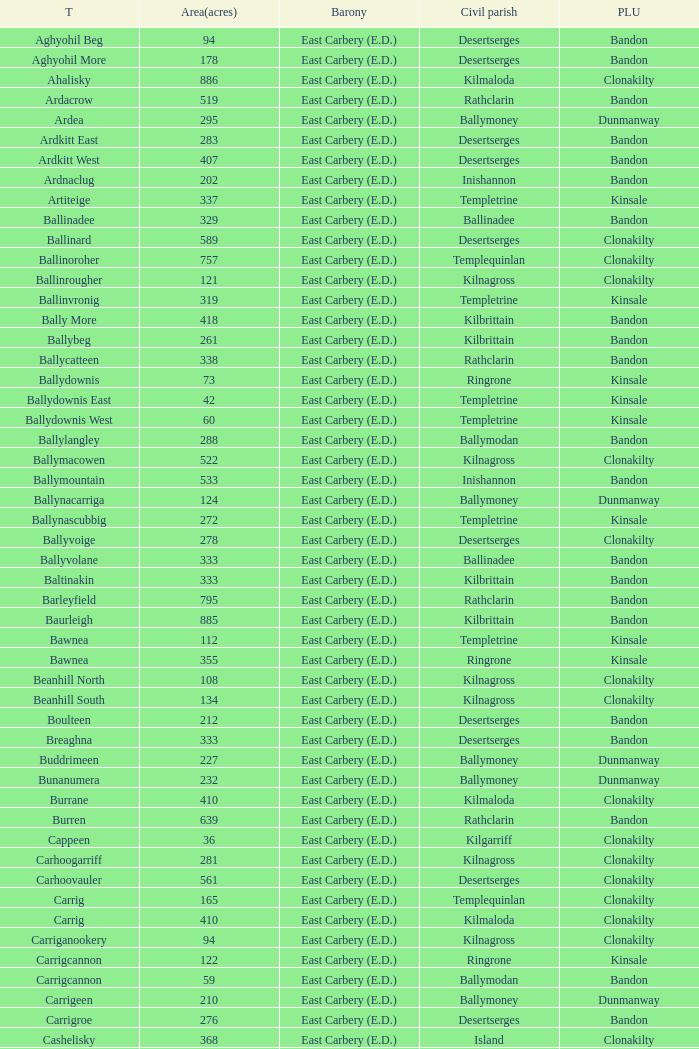What is the maximum area (in acres) of the Knockacullen townland? 381.0. Parse the full table. {'header': ['T', 'Area(acres)', 'Barony', 'Civil parish', 'PLU'], 'rows': [['Aghyohil Beg', '94', 'East Carbery (E.D.)', 'Desertserges', 'Bandon'], ['Aghyohil More', '178', 'East Carbery (E.D.)', 'Desertserges', 'Bandon'], ['Ahalisky', '886', 'East Carbery (E.D.)', 'Kilmaloda', 'Clonakilty'], ['Ardacrow', '519', 'East Carbery (E.D.)', 'Rathclarin', 'Bandon'], ['Ardea', '295', 'East Carbery (E.D.)', 'Ballymoney', 'Dunmanway'], ['Ardkitt East', '283', 'East Carbery (E.D.)', 'Desertserges', 'Bandon'], ['Ardkitt West', '407', 'East Carbery (E.D.)', 'Desertserges', 'Bandon'], ['Ardnaclug', '202', 'East Carbery (E.D.)', 'Inishannon', 'Bandon'], ['Artiteige', '337', 'East Carbery (E.D.)', 'Templetrine', 'Kinsale'], ['Ballinadee', '329', 'East Carbery (E.D.)', 'Ballinadee', 'Bandon'], ['Ballinard', '589', 'East Carbery (E.D.)', 'Desertserges', 'Clonakilty'], ['Ballinoroher', '757', 'East Carbery (E.D.)', 'Templequinlan', 'Clonakilty'], ['Ballinrougher', '121', 'East Carbery (E.D.)', 'Kilnagross', 'Clonakilty'], ['Ballinvronig', '319', 'East Carbery (E.D.)', 'Templetrine', 'Kinsale'], ['Bally More', '418', 'East Carbery (E.D.)', 'Kilbrittain', 'Bandon'], ['Ballybeg', '261', 'East Carbery (E.D.)', 'Kilbrittain', 'Bandon'], ['Ballycatteen', '338', 'East Carbery (E.D.)', 'Rathclarin', 'Bandon'], ['Ballydownis', '73', 'East Carbery (E.D.)', 'Ringrone', 'Kinsale'], ['Ballydownis East', '42', 'East Carbery (E.D.)', 'Templetrine', 'Kinsale'], ['Ballydownis West', '60', 'East Carbery (E.D.)', 'Templetrine', 'Kinsale'], ['Ballylangley', '288', 'East Carbery (E.D.)', 'Ballymodan', 'Bandon'], ['Ballymacowen', '522', 'East Carbery (E.D.)', 'Kilnagross', 'Clonakilty'], ['Ballymountain', '533', 'East Carbery (E.D.)', 'Inishannon', 'Bandon'], ['Ballynacarriga', '124', 'East Carbery (E.D.)', 'Ballymoney', 'Dunmanway'], ['Ballynascubbig', '272', 'East Carbery (E.D.)', 'Templetrine', 'Kinsale'], ['Ballyvoige', '278', 'East Carbery (E.D.)', 'Desertserges', 'Clonakilty'], ['Ballyvolane', '333', 'East Carbery (E.D.)', 'Ballinadee', 'Bandon'], ['Baltinakin', '333', 'East Carbery (E.D.)', 'Kilbrittain', 'Bandon'], ['Barleyfield', '795', 'East Carbery (E.D.)', 'Rathclarin', 'Bandon'], ['Baurleigh', '885', 'East Carbery (E.D.)', 'Kilbrittain', 'Bandon'], ['Bawnea', '112', 'East Carbery (E.D.)', 'Templetrine', 'Kinsale'], ['Bawnea', '355', 'East Carbery (E.D.)', 'Ringrone', 'Kinsale'], ['Beanhill North', '108', 'East Carbery (E.D.)', 'Kilnagross', 'Clonakilty'], ['Beanhill South', '134', 'East Carbery (E.D.)', 'Kilnagross', 'Clonakilty'], ['Boulteen', '212', 'East Carbery (E.D.)', 'Desertserges', 'Bandon'], ['Breaghna', '333', 'East Carbery (E.D.)', 'Desertserges', 'Bandon'], ['Buddrimeen', '227', 'East Carbery (E.D.)', 'Ballymoney', 'Dunmanway'], ['Bunanumera', '232', 'East Carbery (E.D.)', 'Ballymoney', 'Dunmanway'], ['Burrane', '410', 'East Carbery (E.D.)', 'Kilmaloda', 'Clonakilty'], ['Burren', '639', 'East Carbery (E.D.)', 'Rathclarin', 'Bandon'], ['Cappeen', '36', 'East Carbery (E.D.)', 'Kilgarriff', 'Clonakilty'], ['Carhoogarriff', '281', 'East Carbery (E.D.)', 'Kilnagross', 'Clonakilty'], ['Carhoovauler', '561', 'East Carbery (E.D.)', 'Desertserges', 'Clonakilty'], ['Carrig', '165', 'East Carbery (E.D.)', 'Templequinlan', 'Clonakilty'], ['Carrig', '410', 'East Carbery (E.D.)', 'Kilmaloda', 'Clonakilty'], ['Carriganookery', '94', 'East Carbery (E.D.)', 'Kilnagross', 'Clonakilty'], ['Carrigcannon', '122', 'East Carbery (E.D.)', 'Ringrone', 'Kinsale'], ['Carrigcannon', '59', 'East Carbery (E.D.)', 'Ballymodan', 'Bandon'], ['Carrigeen', '210', 'East Carbery (E.D.)', 'Ballymoney', 'Dunmanway'], ['Carrigroe', '276', 'East Carbery (E.D.)', 'Desertserges', 'Bandon'], ['Cashelisky', '368', 'East Carbery (E.D.)', 'Island', 'Clonakilty'], ['Castlederry', '148', 'East Carbery (E.D.)', 'Desertserges', 'Clonakilty'], ['Clashafree', '477', 'East Carbery (E.D.)', 'Ballymodan', 'Bandon'], ['Clashreagh', '132', 'East Carbery (E.D.)', 'Templetrine', 'Kinsale'], ['Clogagh North', '173', 'East Carbery (E.D.)', 'Kilmaloda', 'Clonakilty'], ['Clogagh South', '282', 'East Carbery (E.D.)', 'Kilmaloda', 'Clonakilty'], ['Cloghane', '488', 'East Carbery (E.D.)', 'Ballinadee', 'Bandon'], ['Clogheenavodig', '70', 'East Carbery (E.D.)', 'Ballymodan', 'Bandon'], ['Cloghmacsimon', '258', 'East Carbery (E.D.)', 'Ballymodan', 'Bandon'], ['Cloheen', '360', 'East Carbery (E.D.)', 'Kilgarriff', 'Clonakilty'], ['Cloheen', '80', 'East Carbery (E.D.)', 'Island', 'Clonakilty'], ['Clonbouig', '209', 'East Carbery (E.D.)', 'Templetrine', 'Kinsale'], ['Clonbouig', '219', 'East Carbery (E.D.)', 'Ringrone', 'Kinsale'], ['Cloncouse', '241', 'East Carbery (E.D.)', 'Ballinadee', 'Bandon'], ['Clooncalla Beg', '219', 'East Carbery (E.D.)', 'Rathclarin', 'Bandon'], ['Clooncalla More', '543', 'East Carbery (E.D.)', 'Rathclarin', 'Bandon'], ['Cloonderreen', '291', 'East Carbery (E.D.)', 'Rathclarin', 'Bandon'], ['Coolmain', '450', 'East Carbery (E.D.)', 'Ringrone', 'Kinsale'], ['Corravreeda East', '258', 'East Carbery (E.D.)', 'Ballymodan', 'Bandon'], ['Corravreeda West', '169', 'East Carbery (E.D.)', 'Ballymodan', 'Bandon'], ['Cripplehill', '125', 'East Carbery (E.D.)', 'Ballymodan', 'Bandon'], ['Cripplehill', '93', 'East Carbery (E.D.)', 'Kilbrittain', 'Bandon'], ['Crohane', '91', 'East Carbery (E.D.)', 'Kilnagross', 'Clonakilty'], ['Crohane East', '108', 'East Carbery (E.D.)', 'Desertserges', 'Clonakilty'], ['Crohane West', '69', 'East Carbery (E.D.)', 'Desertserges', 'Clonakilty'], ['Crohane (or Bandon)', '204', 'East Carbery (E.D.)', 'Desertserges', 'Clonakilty'], ['Crohane (or Bandon)', '250', 'East Carbery (E.D.)', 'Kilnagross', 'Clonakilty'], ['Currabeg', '173', 'East Carbery (E.D.)', 'Ballymoney', 'Dunmanway'], ['Curraghcrowly East', '327', 'East Carbery (E.D.)', 'Ballymoney', 'Dunmanway'], ['Curraghcrowly West', '242', 'East Carbery (E.D.)', 'Ballymoney', 'Dunmanway'], ['Curraghgrane More', '110', 'East Carbery (E.D.)', 'Desert', 'Clonakilty'], ['Currane', '156', 'East Carbery (E.D.)', 'Desertserges', 'Clonakilty'], ['Curranure', '362', 'East Carbery (E.D.)', 'Inishannon', 'Bandon'], ['Currarane', '100', 'East Carbery (E.D.)', 'Templetrine', 'Kinsale'], ['Currarane', '271', 'East Carbery (E.D.)', 'Ringrone', 'Kinsale'], ['Derrigra', '177', 'East Carbery (E.D.)', 'Ballymoney', 'Dunmanway'], ['Derrigra West', '320', 'East Carbery (E.D.)', 'Ballymoney', 'Dunmanway'], ['Derry', '140', 'East Carbery (E.D.)', 'Desertserges', 'Clonakilty'], ['Derrymeeleen', '441', 'East Carbery (E.D.)', 'Desertserges', 'Clonakilty'], ['Desert', '339', 'East Carbery (E.D.)', 'Desert', 'Clonakilty'], ['Drombofinny', '86', 'East Carbery (E.D.)', 'Desertserges', 'Bandon'], ['Dromgarriff', '335', 'East Carbery (E.D.)', 'Kilmaloda', 'Clonakilty'], ['Dromgarriff East', '385', 'East Carbery (E.D.)', 'Kilnagross', 'Clonakilty'], ['Dromgarriff West', '138', 'East Carbery (E.D.)', 'Kilnagross', 'Clonakilty'], ['Dromkeen', '673', 'East Carbery (E.D.)', 'Inishannon', 'Bandon'], ['Edencurra', '516', 'East Carbery (E.D.)', 'Ballymoney', 'Dunmanway'], ['Farran', '502', 'East Carbery (E.D.)', 'Kilmaloda', 'Clonakilty'], ['Farranagow', '99', 'East Carbery (E.D.)', 'Inishannon', 'Bandon'], ['Farrannagark', '290', 'East Carbery (E.D.)', 'Rathclarin', 'Bandon'], ['Farrannasheshery', '304', 'East Carbery (E.D.)', 'Desertserges', 'Bandon'], ['Fourcuil', '125', 'East Carbery (E.D.)', 'Kilgarriff', 'Clonakilty'], ['Fourcuil', '244', 'East Carbery (E.D.)', 'Templebryan', 'Clonakilty'], ['Garranbeg', '170', 'East Carbery (E.D.)', 'Ballymodan', 'Bandon'], ['Garraneanasig', '270', 'East Carbery (E.D.)', 'Ringrone', 'Kinsale'], ['Garraneard', '276', 'East Carbery (E.D.)', 'Kilnagross', 'Clonakilty'], ['Garranecore', '144', 'East Carbery (E.D.)', 'Templebryan', 'Clonakilty'], ['Garranecore', '186', 'East Carbery (E.D.)', 'Kilgarriff', 'Clonakilty'], ['Garranefeen', '478', 'East Carbery (E.D.)', 'Rathclarin', 'Bandon'], ['Garraneishal', '121', 'East Carbery (E.D.)', 'Kilnagross', 'Clonakilty'], ['Garranelahan', '126', 'East Carbery (E.D.)', 'Desertserges', 'Bandon'], ['Garranereagh', '398', 'East Carbery (E.D.)', 'Ringrone', 'Kinsale'], ['Garranes', '416', 'East Carbery (E.D.)', 'Desertserges', 'Clonakilty'], ['Garranure', '436', 'East Carbery (E.D.)', 'Ballymoney', 'Dunmanway'], ['Garryndruig', '856', 'East Carbery (E.D.)', 'Rathclarin', 'Bandon'], ['Glan', '194', 'East Carbery (E.D.)', 'Ballymoney', 'Dunmanway'], ['Glanavaud', '98', 'East Carbery (E.D.)', 'Ringrone', 'Kinsale'], ['Glanavirane', '107', 'East Carbery (E.D.)', 'Templetrine', 'Kinsale'], ['Glanavirane', '91', 'East Carbery (E.D.)', 'Ringrone', 'Kinsale'], ['Glanduff', '464', 'East Carbery (E.D.)', 'Rathclarin', 'Bandon'], ['Grillagh', '136', 'East Carbery (E.D.)', 'Kilnagross', 'Clonakilty'], ['Grillagh', '316', 'East Carbery (E.D.)', 'Ballymoney', 'Dunmanway'], ['Hacketstown', '182', 'East Carbery (E.D.)', 'Templetrine', 'Kinsale'], ['Inchafune', '871', 'East Carbery (E.D.)', 'Ballymoney', 'Dunmanway'], ['Inchydoney Island', '474', 'East Carbery (E.D.)', 'Island', 'Clonakilty'], ['Kilbeloge', '216', 'East Carbery (E.D.)', 'Desertserges', 'Clonakilty'], ['Kilbree', '284', 'East Carbery (E.D.)', 'Island', 'Clonakilty'], ['Kilbrittain', '483', 'East Carbery (E.D.)', 'Kilbrittain', 'Bandon'], ['Kilcaskan', '221', 'East Carbery (E.D.)', 'Ballymoney', 'Dunmanway'], ['Kildarra', '463', 'East Carbery (E.D.)', 'Ballinadee', 'Bandon'], ['Kilgarriff', '835', 'East Carbery (E.D.)', 'Kilgarriff', 'Clonakilty'], ['Kilgobbin', '1263', 'East Carbery (E.D.)', 'Ballinadee', 'Bandon'], ['Kill North', '136', 'East Carbery (E.D.)', 'Desertserges', 'Clonakilty'], ['Kill South', '139', 'East Carbery (E.D.)', 'Desertserges', 'Clonakilty'], ['Killanamaul', '220', 'East Carbery (E.D.)', 'Kilbrittain', 'Bandon'], ['Killaneetig', '342', 'East Carbery (E.D.)', 'Ballinadee', 'Bandon'], ['Killavarrig', '708', 'East Carbery (E.D.)', 'Timoleague', 'Clonakilty'], ['Killeen', '309', 'East Carbery (E.D.)', 'Desertserges', 'Clonakilty'], ['Killeens', '132', 'East Carbery (E.D.)', 'Templetrine', 'Kinsale'], ['Kilmacsimon', '219', 'East Carbery (E.D.)', 'Ballinadee', 'Bandon'], ['Kilmaloda', '634', 'East Carbery (E.D.)', 'Kilmaloda', 'Clonakilty'], ['Kilmoylerane North', '306', 'East Carbery (E.D.)', 'Desertserges', 'Clonakilty'], ['Kilmoylerane South', '324', 'East Carbery (E.D.)', 'Desertserges', 'Clonakilty'], ['Kilnameela', '397', 'East Carbery (E.D.)', 'Desertserges', 'Bandon'], ['Kilrush', '189', 'East Carbery (E.D.)', 'Desertserges', 'Bandon'], ['Kilshinahan', '528', 'East Carbery (E.D.)', 'Kilbrittain', 'Bandon'], ['Kilvinane', '199', 'East Carbery (E.D.)', 'Ballymoney', 'Dunmanway'], ['Kilvurra', '356', 'East Carbery (E.D.)', 'Ballymoney', 'Dunmanway'], ['Knockacullen', '381', 'East Carbery (E.D.)', 'Desertserges', 'Clonakilty'], ['Knockaneady', '393', 'East Carbery (E.D.)', 'Ballymoney', 'Dunmanway'], ['Knockaneroe', '127', 'East Carbery (E.D.)', 'Templetrine', 'Kinsale'], ['Knockanreagh', '139', 'East Carbery (E.D.)', 'Ballymodan', 'Bandon'], ['Knockbrown', '312', 'East Carbery (E.D.)', 'Kilbrittain', 'Bandon'], ['Knockbrown', '510', 'East Carbery (E.D.)', 'Kilmaloda', 'Bandon'], ['Knockeenbwee Lower', '213', 'East Carbery (E.D.)', 'Dromdaleague', 'Skibbereen'], ['Knockeenbwee Upper', '229', 'East Carbery (E.D.)', 'Dromdaleague', 'Skibbereen'], ['Knockeencon', '108', 'East Carbery (E.D.)', 'Tullagh', 'Skibbereen'], ['Knockmacool', '241', 'East Carbery (E.D.)', 'Desertserges', 'Bandon'], ['Knocknacurra', '422', 'East Carbery (E.D.)', 'Ballinadee', 'Bandon'], ['Knocknagappul', '507', 'East Carbery (E.D.)', 'Ballinadee', 'Bandon'], ['Knocknanuss', '394', 'East Carbery (E.D.)', 'Desertserges', 'Clonakilty'], ['Knocknastooka', '118', 'East Carbery (E.D.)', 'Desertserges', 'Bandon'], ['Knockroe', '601', 'East Carbery (E.D.)', 'Inishannon', 'Bandon'], ['Knocks', '540', 'East Carbery (E.D.)', 'Desertserges', 'Clonakilty'], ['Knockskagh', '489', 'East Carbery (E.D.)', 'Kilgarriff', 'Clonakilty'], ['Knoppoge', '567', 'East Carbery (E.D.)', 'Kilbrittain', 'Bandon'], ['Lackanalooha', '209', 'East Carbery (E.D.)', 'Kilnagross', 'Clonakilty'], ['Lackenagobidane', '48', 'East Carbery (E.D.)', 'Island', 'Clonakilty'], ['Lisbehegh', '255', 'East Carbery (E.D.)', 'Desertserges', 'Clonakilty'], ['Lisheen', '44', 'East Carbery (E.D.)', 'Templetrine', 'Kinsale'], ['Lisheenaleen', '267', 'East Carbery (E.D.)', 'Rathclarin', 'Bandon'], ['Lisnacunna', '529', 'East Carbery (E.D.)', 'Desertserges', 'Bandon'], ['Lisroe', '91', 'East Carbery (E.D.)', 'Kilgarriff', 'Clonakilty'], ['Lissaphooca', '513', 'East Carbery (E.D.)', 'Ballymodan', 'Bandon'], ['Lisselane', '429', 'East Carbery (E.D.)', 'Kilnagross', 'Clonakilty'], ['Madame', '273', 'East Carbery (E.D.)', 'Kilmaloda', 'Clonakilty'], ['Madame', '41', 'East Carbery (E.D.)', 'Kilnagross', 'Clonakilty'], ['Maulbrack East', '100', 'East Carbery (E.D.)', 'Desertserges', 'Bandon'], ['Maulbrack West', '242', 'East Carbery (E.D.)', 'Desertserges', 'Bandon'], ['Maulmane', '219', 'East Carbery (E.D.)', 'Kilbrittain', 'Bandon'], ['Maulnageragh', '135', 'East Carbery (E.D.)', 'Kilnagross', 'Clonakilty'], ['Maulnarouga North', '81', 'East Carbery (E.D.)', 'Desertserges', 'Bandon'], ['Maulnarouga South', '374', 'East Carbery (E.D.)', 'Desertserges', 'Bandon'], ['Maulnaskehy', '14', 'East Carbery (E.D.)', 'Kilgarriff', 'Clonakilty'], ['Maulrour', '244', 'East Carbery (E.D.)', 'Desertserges', 'Clonakilty'], ['Maulrour', '340', 'East Carbery (E.D.)', 'Kilmaloda', 'Clonakilty'], ['Maulskinlahane', '245', 'East Carbery (E.D.)', 'Kilbrittain', 'Bandon'], ['Miles', '268', 'East Carbery (E.D.)', 'Kilgarriff', 'Clonakilty'], ['Moanarone', '235', 'East Carbery (E.D.)', 'Ballymodan', 'Bandon'], ['Monteen', '589', 'East Carbery (E.D.)', 'Kilmaloda', 'Clonakilty'], ['Phale Lower', '287', 'East Carbery (E.D.)', 'Ballymoney', 'Dunmanway'], ['Phale Upper', '234', 'East Carbery (E.D.)', 'Ballymoney', 'Dunmanway'], ['Ratharoon East', '810', 'East Carbery (E.D.)', 'Ballinadee', 'Bandon'], ['Ratharoon West', '383', 'East Carbery (E.D.)', 'Ballinadee', 'Bandon'], ['Rathdrought', '1242', 'East Carbery (E.D.)', 'Ballinadee', 'Bandon'], ['Reengarrigeen', '560', 'East Carbery (E.D.)', 'Kilmaloda', 'Clonakilty'], ['Reenroe', '123', 'East Carbery (E.D.)', 'Kilgarriff', 'Clonakilty'], ['Rochestown', '104', 'East Carbery (E.D.)', 'Templetrine', 'Kinsale'], ['Rockfort', '308', 'East Carbery (E.D.)', 'Brinny', 'Bandon'], ['Rockhouse', '82', 'East Carbery (E.D.)', 'Ballinadee', 'Bandon'], ['Scartagh', '186', 'East Carbery (E.D.)', 'Kilgarriff', 'Clonakilty'], ['Shanakill', '197', 'East Carbery (E.D.)', 'Rathclarin', 'Bandon'], ['Shanaway East', '386', 'East Carbery (E.D.)', 'Ballymoney', 'Dunmanway'], ['Shanaway Middle', '296', 'East Carbery (E.D.)', 'Ballymoney', 'Dunmanway'], ['Shanaway West', '266', 'East Carbery (E.D.)', 'Ballymoney', 'Dunmanway'], ['Skeaf', '452', 'East Carbery (E.D.)', 'Kilmaloda', 'Clonakilty'], ['Skeaf East', '371', 'East Carbery (E.D.)', 'Kilmaloda', 'Clonakilty'], ['Skeaf West', '477', 'East Carbery (E.D.)', 'Kilmaloda', 'Clonakilty'], ['Skevanish', '359', 'East Carbery (E.D.)', 'Inishannon', 'Bandon'], ['Steilaneigh', '42', 'East Carbery (E.D.)', 'Templetrine', 'Kinsale'], ['Tawnies Lower', '238', 'East Carbery (E.D.)', 'Kilgarriff', 'Clonakilty'], ['Tawnies Upper', '321', 'East Carbery (E.D.)', 'Kilgarriff', 'Clonakilty'], ['Templebryan North', '436', 'East Carbery (E.D.)', 'Templebryan', 'Clonakilty'], ['Templebryan South', '363', 'East Carbery (E.D.)', 'Templebryan', 'Clonakilty'], ['Tullig', '135', 'East Carbery (E.D.)', 'Kilmaloda', 'Clonakilty'], ['Tullyland', '348', 'East Carbery (E.D.)', 'Ballymodan', 'Bandon'], ['Tullyland', '506', 'East Carbery (E.D.)', 'Ballinadee', 'Bandon'], ['Tullymurrihy', '665', 'East Carbery (E.D.)', 'Desertserges', 'Bandon'], ['Youghals', '109', 'East Carbery (E.D.)', 'Island', 'Clonakilty']]} 